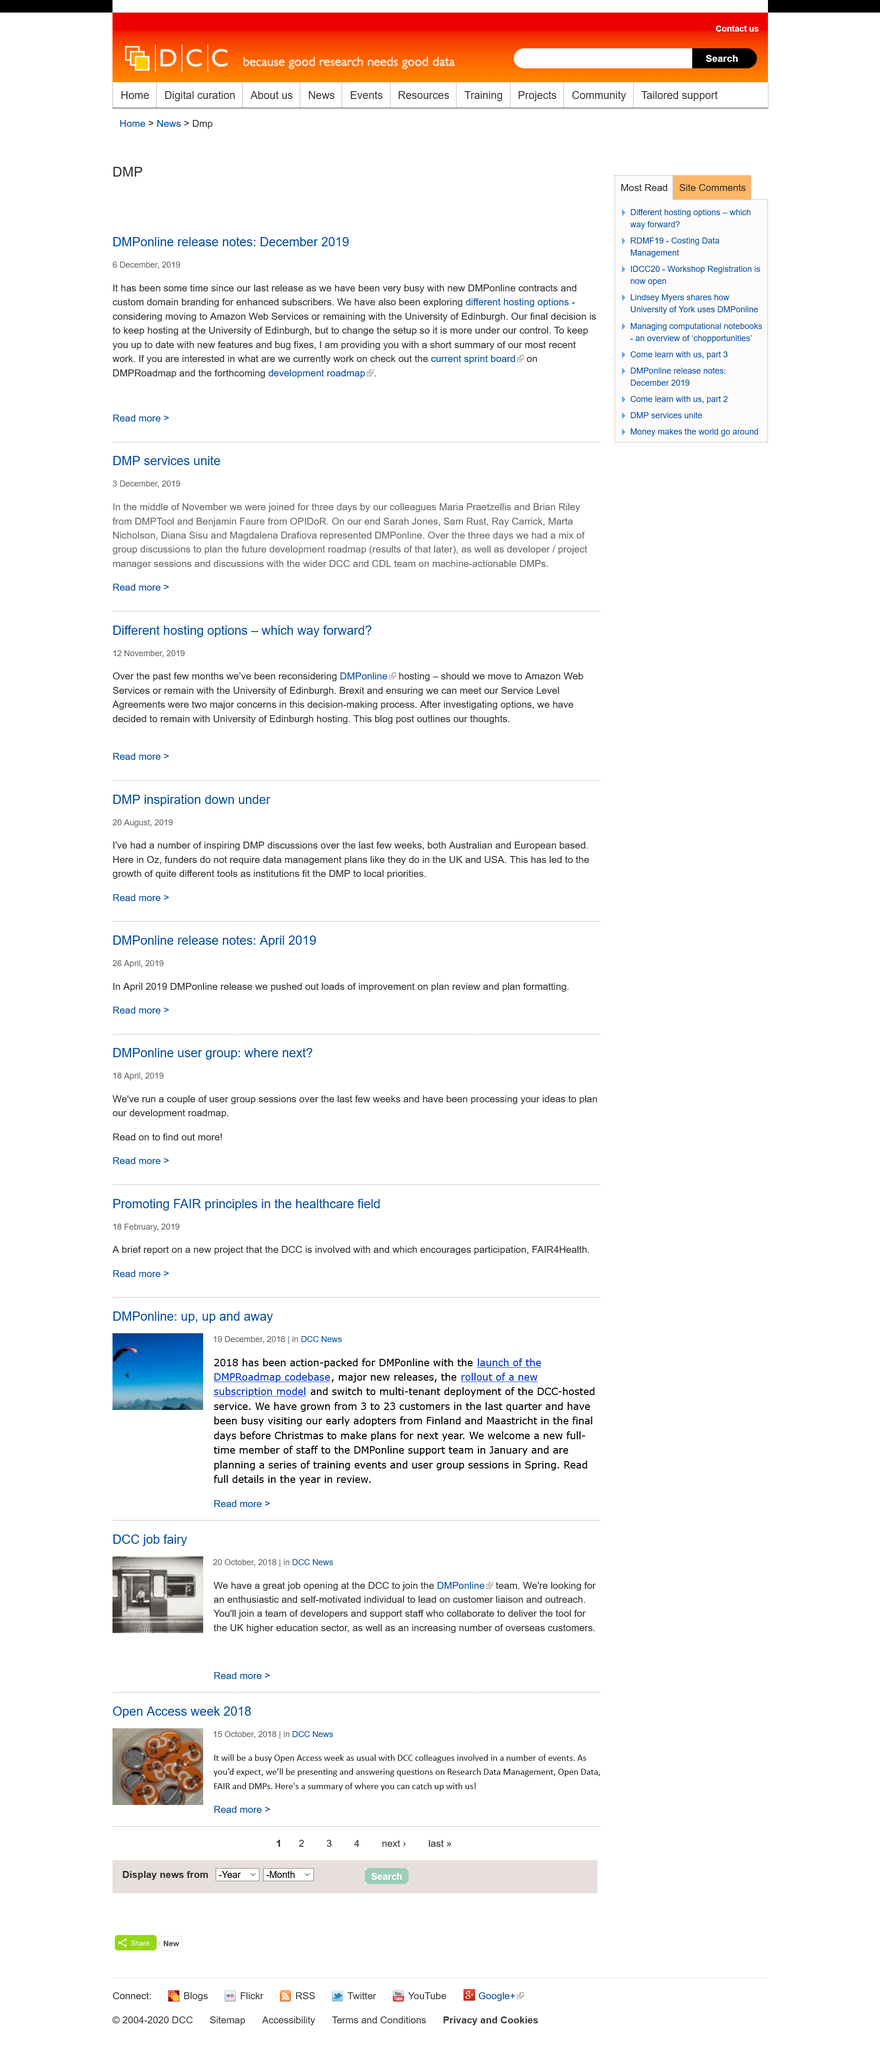Identify some key points in this picture. The two hosting options mentioned are those provided by Amazon Web Services and the University of Edinburgh. The colleague from OPIDoR is named Benjamin Faure. The dates December 3, 2019, and December 6, 2019, are shown. 